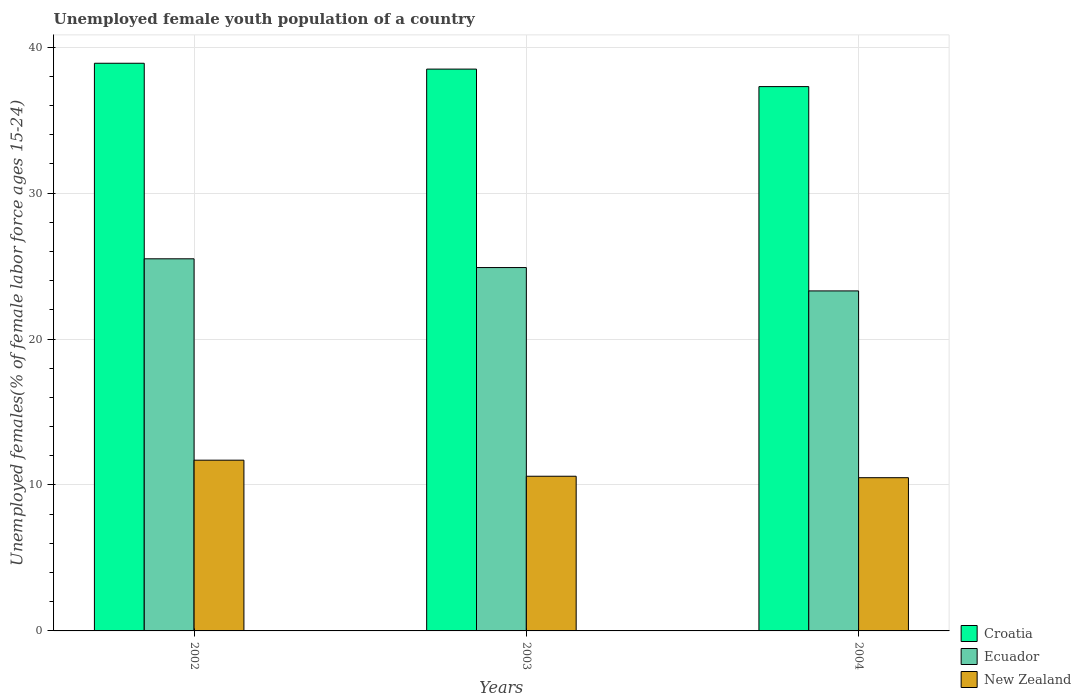How many bars are there on the 2nd tick from the right?
Offer a very short reply. 3. What is the percentage of unemployed female youth population in Croatia in 2003?
Give a very brief answer. 38.5. Across all years, what is the maximum percentage of unemployed female youth population in Ecuador?
Ensure brevity in your answer.  25.5. Across all years, what is the minimum percentage of unemployed female youth population in Croatia?
Ensure brevity in your answer.  37.3. In which year was the percentage of unemployed female youth population in Ecuador minimum?
Offer a terse response. 2004. What is the total percentage of unemployed female youth population in Croatia in the graph?
Provide a succinct answer. 114.7. What is the difference between the percentage of unemployed female youth population in Croatia in 2002 and that in 2003?
Keep it short and to the point. 0.4. What is the difference between the percentage of unemployed female youth population in Ecuador in 2002 and the percentage of unemployed female youth population in Croatia in 2004?
Give a very brief answer. -11.8. What is the average percentage of unemployed female youth population in Croatia per year?
Offer a terse response. 38.23. In the year 2003, what is the difference between the percentage of unemployed female youth population in New Zealand and percentage of unemployed female youth population in Ecuador?
Provide a succinct answer. -14.3. What is the ratio of the percentage of unemployed female youth population in Croatia in 2002 to that in 2003?
Keep it short and to the point. 1.01. What is the difference between the highest and the second highest percentage of unemployed female youth population in New Zealand?
Offer a terse response. 1.1. What is the difference between the highest and the lowest percentage of unemployed female youth population in Croatia?
Offer a very short reply. 1.6. What does the 1st bar from the left in 2003 represents?
Your answer should be compact. Croatia. What does the 1st bar from the right in 2004 represents?
Keep it short and to the point. New Zealand. Is it the case that in every year, the sum of the percentage of unemployed female youth population in Croatia and percentage of unemployed female youth population in New Zealand is greater than the percentage of unemployed female youth population in Ecuador?
Give a very brief answer. Yes. Are all the bars in the graph horizontal?
Offer a terse response. No. How many years are there in the graph?
Give a very brief answer. 3. What is the difference between two consecutive major ticks on the Y-axis?
Give a very brief answer. 10. Are the values on the major ticks of Y-axis written in scientific E-notation?
Your response must be concise. No. Does the graph contain grids?
Ensure brevity in your answer.  Yes. How many legend labels are there?
Your response must be concise. 3. What is the title of the graph?
Provide a succinct answer. Unemployed female youth population of a country. Does "Grenada" appear as one of the legend labels in the graph?
Keep it short and to the point. No. What is the label or title of the Y-axis?
Provide a short and direct response. Unemployed females(% of female labor force ages 15-24). What is the Unemployed females(% of female labor force ages 15-24) of Croatia in 2002?
Give a very brief answer. 38.9. What is the Unemployed females(% of female labor force ages 15-24) of New Zealand in 2002?
Your answer should be compact. 11.7. What is the Unemployed females(% of female labor force ages 15-24) in Croatia in 2003?
Make the answer very short. 38.5. What is the Unemployed females(% of female labor force ages 15-24) in Ecuador in 2003?
Offer a terse response. 24.9. What is the Unemployed females(% of female labor force ages 15-24) of New Zealand in 2003?
Offer a very short reply. 10.6. What is the Unemployed females(% of female labor force ages 15-24) in Croatia in 2004?
Provide a short and direct response. 37.3. What is the Unemployed females(% of female labor force ages 15-24) of Ecuador in 2004?
Offer a terse response. 23.3. What is the Unemployed females(% of female labor force ages 15-24) in New Zealand in 2004?
Give a very brief answer. 10.5. Across all years, what is the maximum Unemployed females(% of female labor force ages 15-24) in Croatia?
Keep it short and to the point. 38.9. Across all years, what is the maximum Unemployed females(% of female labor force ages 15-24) in New Zealand?
Give a very brief answer. 11.7. Across all years, what is the minimum Unemployed females(% of female labor force ages 15-24) of Croatia?
Provide a short and direct response. 37.3. Across all years, what is the minimum Unemployed females(% of female labor force ages 15-24) in Ecuador?
Keep it short and to the point. 23.3. What is the total Unemployed females(% of female labor force ages 15-24) of Croatia in the graph?
Give a very brief answer. 114.7. What is the total Unemployed females(% of female labor force ages 15-24) in Ecuador in the graph?
Provide a short and direct response. 73.7. What is the total Unemployed females(% of female labor force ages 15-24) in New Zealand in the graph?
Keep it short and to the point. 32.8. What is the difference between the Unemployed females(% of female labor force ages 15-24) in Ecuador in 2002 and that in 2004?
Provide a short and direct response. 2.2. What is the difference between the Unemployed females(% of female labor force ages 15-24) of New Zealand in 2002 and that in 2004?
Make the answer very short. 1.2. What is the difference between the Unemployed females(% of female labor force ages 15-24) in New Zealand in 2003 and that in 2004?
Keep it short and to the point. 0.1. What is the difference between the Unemployed females(% of female labor force ages 15-24) in Croatia in 2002 and the Unemployed females(% of female labor force ages 15-24) in New Zealand in 2003?
Offer a terse response. 28.3. What is the difference between the Unemployed females(% of female labor force ages 15-24) in Ecuador in 2002 and the Unemployed females(% of female labor force ages 15-24) in New Zealand in 2003?
Your response must be concise. 14.9. What is the difference between the Unemployed females(% of female labor force ages 15-24) of Croatia in 2002 and the Unemployed females(% of female labor force ages 15-24) of Ecuador in 2004?
Your answer should be very brief. 15.6. What is the difference between the Unemployed females(% of female labor force ages 15-24) of Croatia in 2002 and the Unemployed females(% of female labor force ages 15-24) of New Zealand in 2004?
Offer a very short reply. 28.4. What is the difference between the Unemployed females(% of female labor force ages 15-24) of Croatia in 2003 and the Unemployed females(% of female labor force ages 15-24) of Ecuador in 2004?
Keep it short and to the point. 15.2. What is the difference between the Unemployed females(% of female labor force ages 15-24) of Croatia in 2003 and the Unemployed females(% of female labor force ages 15-24) of New Zealand in 2004?
Offer a terse response. 28. What is the average Unemployed females(% of female labor force ages 15-24) of Croatia per year?
Your answer should be compact. 38.23. What is the average Unemployed females(% of female labor force ages 15-24) of Ecuador per year?
Offer a terse response. 24.57. What is the average Unemployed females(% of female labor force ages 15-24) in New Zealand per year?
Offer a very short reply. 10.93. In the year 2002, what is the difference between the Unemployed females(% of female labor force ages 15-24) in Croatia and Unemployed females(% of female labor force ages 15-24) in Ecuador?
Provide a succinct answer. 13.4. In the year 2002, what is the difference between the Unemployed females(% of female labor force ages 15-24) of Croatia and Unemployed females(% of female labor force ages 15-24) of New Zealand?
Ensure brevity in your answer.  27.2. In the year 2002, what is the difference between the Unemployed females(% of female labor force ages 15-24) of Ecuador and Unemployed females(% of female labor force ages 15-24) of New Zealand?
Provide a succinct answer. 13.8. In the year 2003, what is the difference between the Unemployed females(% of female labor force ages 15-24) in Croatia and Unemployed females(% of female labor force ages 15-24) in Ecuador?
Offer a very short reply. 13.6. In the year 2003, what is the difference between the Unemployed females(% of female labor force ages 15-24) in Croatia and Unemployed females(% of female labor force ages 15-24) in New Zealand?
Your answer should be very brief. 27.9. In the year 2004, what is the difference between the Unemployed females(% of female labor force ages 15-24) of Croatia and Unemployed females(% of female labor force ages 15-24) of Ecuador?
Ensure brevity in your answer.  14. In the year 2004, what is the difference between the Unemployed females(% of female labor force ages 15-24) in Croatia and Unemployed females(% of female labor force ages 15-24) in New Zealand?
Provide a short and direct response. 26.8. In the year 2004, what is the difference between the Unemployed females(% of female labor force ages 15-24) of Ecuador and Unemployed females(% of female labor force ages 15-24) of New Zealand?
Your answer should be very brief. 12.8. What is the ratio of the Unemployed females(% of female labor force ages 15-24) of Croatia in 2002 to that in 2003?
Ensure brevity in your answer.  1.01. What is the ratio of the Unemployed females(% of female labor force ages 15-24) in Ecuador in 2002 to that in 2003?
Provide a short and direct response. 1.02. What is the ratio of the Unemployed females(% of female labor force ages 15-24) in New Zealand in 2002 to that in 2003?
Your answer should be compact. 1.1. What is the ratio of the Unemployed females(% of female labor force ages 15-24) of Croatia in 2002 to that in 2004?
Offer a terse response. 1.04. What is the ratio of the Unemployed females(% of female labor force ages 15-24) of Ecuador in 2002 to that in 2004?
Keep it short and to the point. 1.09. What is the ratio of the Unemployed females(% of female labor force ages 15-24) in New Zealand in 2002 to that in 2004?
Your answer should be very brief. 1.11. What is the ratio of the Unemployed females(% of female labor force ages 15-24) of Croatia in 2003 to that in 2004?
Keep it short and to the point. 1.03. What is the ratio of the Unemployed females(% of female labor force ages 15-24) in Ecuador in 2003 to that in 2004?
Keep it short and to the point. 1.07. What is the ratio of the Unemployed females(% of female labor force ages 15-24) of New Zealand in 2003 to that in 2004?
Ensure brevity in your answer.  1.01. What is the difference between the highest and the second highest Unemployed females(% of female labor force ages 15-24) of Croatia?
Your answer should be compact. 0.4. What is the difference between the highest and the lowest Unemployed females(% of female labor force ages 15-24) of Croatia?
Give a very brief answer. 1.6. What is the difference between the highest and the lowest Unemployed females(% of female labor force ages 15-24) of New Zealand?
Offer a very short reply. 1.2. 